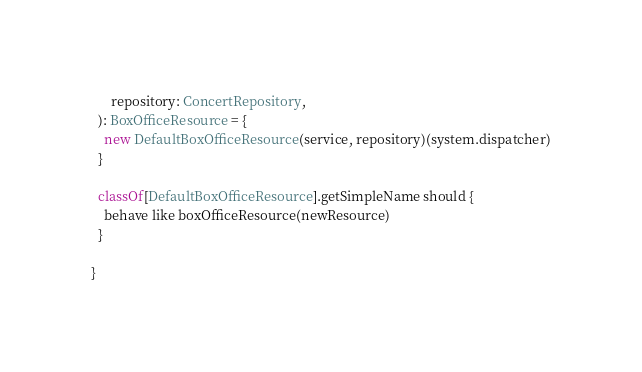<code> <loc_0><loc_0><loc_500><loc_500><_Scala_>      repository: ConcertRepository,
  ): BoxOfficeResource = {
    new DefaultBoxOfficeResource(service, repository)(system.dispatcher)
  }

  classOf[DefaultBoxOfficeResource].getSimpleName should {
    behave like boxOfficeResource(newResource)
  }

}
</code> 